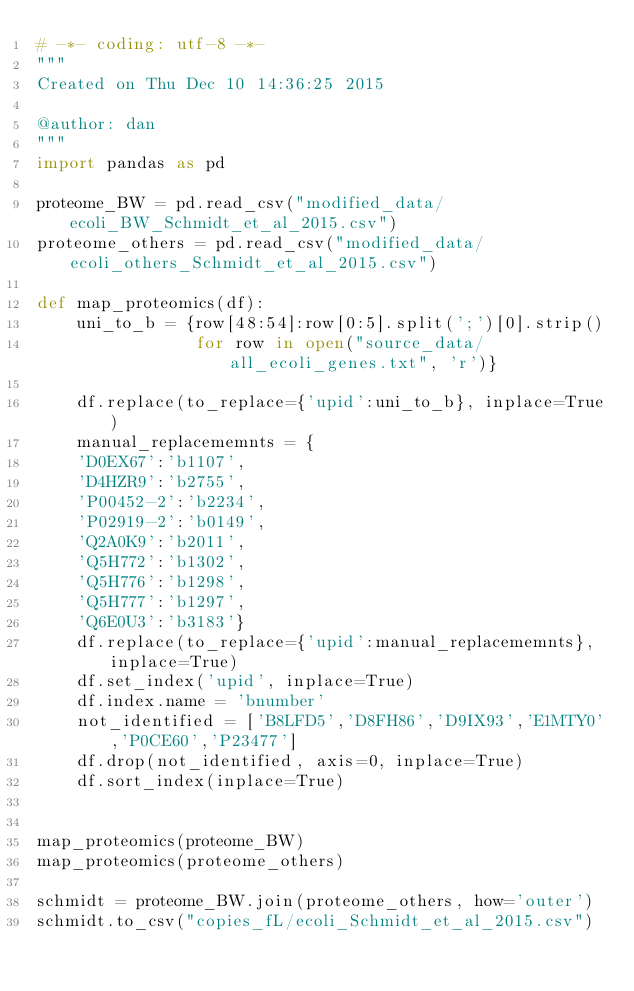<code> <loc_0><loc_0><loc_500><loc_500><_Python_># -*- coding: utf-8 -*-
"""
Created on Thu Dec 10 14:36:25 2015

@author: dan
"""
import pandas as pd

proteome_BW = pd.read_csv("modified_data/ecoli_BW_Schmidt_et_al_2015.csv")
proteome_others = pd.read_csv("modified_data/ecoli_others_Schmidt_et_al_2015.csv")

def map_proteomics(df):
    uni_to_b = {row[48:54]:row[0:5].split(';')[0].strip()
                for row in open("source_data/all_ecoli_genes.txt", 'r')}
    
    df.replace(to_replace={'upid':uni_to_b}, inplace=True)
    manual_replacememnts = {
    'D0EX67':'b1107',
    'D4HZR9':'b2755',
    'P00452-2':'b2234',
    'P02919-2':'b0149',
    'Q2A0K9':'b2011',
    'Q5H772':'b1302',
    'Q5H776':'b1298',
    'Q5H777':'b1297',
    'Q6E0U3':'b3183'}
    df.replace(to_replace={'upid':manual_replacememnts}, inplace=True)
    df.set_index('upid', inplace=True)                                
    df.index.name = 'bnumber'
    not_identified = ['B8LFD5','D8FH86','D9IX93','E1MTY0','P0CE60','P23477']
    df.drop(not_identified, axis=0, inplace=True)
    df.sort_index(inplace=True)    
    

map_proteomics(proteome_BW)
map_proteomics(proteome_others)

schmidt = proteome_BW.join(proteome_others, how='outer')
schmidt.to_csv("copies_fL/ecoli_Schmidt_et_al_2015.csv")</code> 